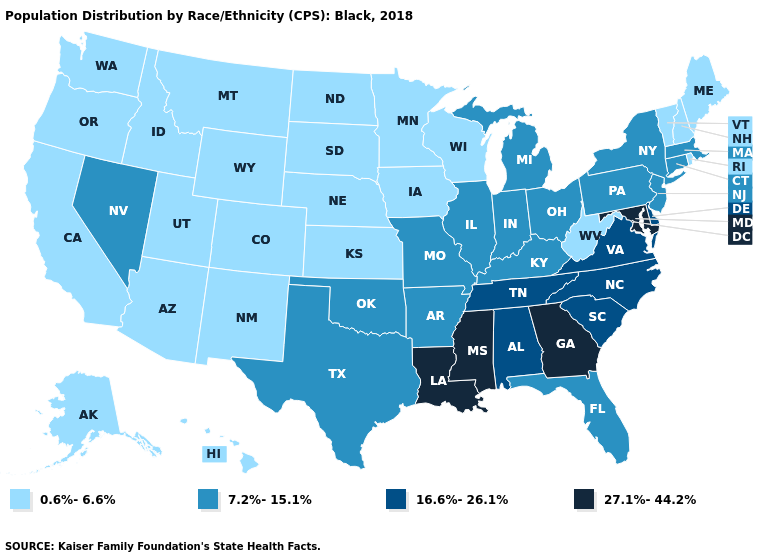Among the states that border Connecticut , does Rhode Island have the highest value?
Write a very short answer. No. Name the states that have a value in the range 0.6%-6.6%?
Be succinct. Alaska, Arizona, California, Colorado, Hawaii, Idaho, Iowa, Kansas, Maine, Minnesota, Montana, Nebraska, New Hampshire, New Mexico, North Dakota, Oregon, Rhode Island, South Dakota, Utah, Vermont, Washington, West Virginia, Wisconsin, Wyoming. Does the first symbol in the legend represent the smallest category?
Be succinct. Yes. What is the value of New Mexico?
Answer briefly. 0.6%-6.6%. Does the map have missing data?
Give a very brief answer. No. Name the states that have a value in the range 16.6%-26.1%?
Keep it brief. Alabama, Delaware, North Carolina, South Carolina, Tennessee, Virginia. Does Rhode Island have the highest value in the Northeast?
Write a very short answer. No. Name the states that have a value in the range 27.1%-44.2%?
Be succinct. Georgia, Louisiana, Maryland, Mississippi. Does Kansas have the same value as Nevada?
Quick response, please. No. Name the states that have a value in the range 0.6%-6.6%?
Quick response, please. Alaska, Arizona, California, Colorado, Hawaii, Idaho, Iowa, Kansas, Maine, Minnesota, Montana, Nebraska, New Hampshire, New Mexico, North Dakota, Oregon, Rhode Island, South Dakota, Utah, Vermont, Washington, West Virginia, Wisconsin, Wyoming. Does the map have missing data?
Answer briefly. No. Does North Dakota have a higher value than Alaska?
Short answer required. No. Name the states that have a value in the range 27.1%-44.2%?
Concise answer only. Georgia, Louisiana, Maryland, Mississippi. Name the states that have a value in the range 7.2%-15.1%?
Short answer required. Arkansas, Connecticut, Florida, Illinois, Indiana, Kentucky, Massachusetts, Michigan, Missouri, Nevada, New Jersey, New York, Ohio, Oklahoma, Pennsylvania, Texas. 